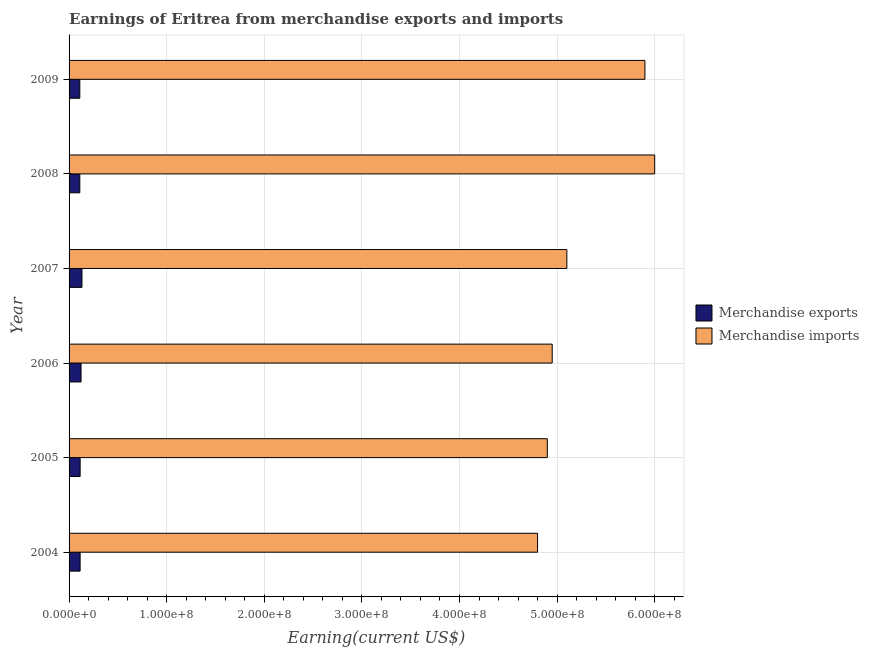How many different coloured bars are there?
Your answer should be very brief. 2. How many groups of bars are there?
Your answer should be very brief. 6. Are the number of bars per tick equal to the number of legend labels?
Keep it short and to the point. Yes. How many bars are there on the 1st tick from the top?
Ensure brevity in your answer.  2. What is the label of the 4th group of bars from the top?
Provide a short and direct response. 2006. In how many cases, is the number of bars for a given year not equal to the number of legend labels?
Provide a succinct answer. 0. What is the earnings from merchandise imports in 2005?
Ensure brevity in your answer.  4.90e+08. Across all years, what is the maximum earnings from merchandise imports?
Offer a terse response. 6.00e+08. Across all years, what is the minimum earnings from merchandise imports?
Make the answer very short. 4.80e+08. In which year was the earnings from merchandise imports maximum?
Your answer should be very brief. 2008. What is the total earnings from merchandise exports in the graph?
Give a very brief answer. 7.01e+07. What is the difference between the earnings from merchandise exports in 2005 and that in 2007?
Offer a very short reply. -1.90e+06. What is the difference between the earnings from merchandise imports in 2008 and the earnings from merchandise exports in 2004?
Keep it short and to the point. 5.89e+08. What is the average earnings from merchandise exports per year?
Your answer should be very brief. 1.17e+07. In the year 2005, what is the difference between the earnings from merchandise imports and earnings from merchandise exports?
Provide a succinct answer. 4.79e+08. What is the ratio of the earnings from merchandise imports in 2006 to that in 2007?
Provide a succinct answer. 0.97. Is the earnings from merchandise imports in 2005 less than that in 2006?
Ensure brevity in your answer.  Yes. What is the difference between the highest and the lowest earnings from merchandise exports?
Keep it short and to the point. 2.22e+06. What does the 2nd bar from the top in 2006 represents?
Offer a very short reply. Merchandise exports. Are all the bars in the graph horizontal?
Keep it short and to the point. Yes. Does the graph contain any zero values?
Provide a short and direct response. No. How are the legend labels stacked?
Provide a short and direct response. Vertical. What is the title of the graph?
Provide a succinct answer. Earnings of Eritrea from merchandise exports and imports. Does "Not attending school" appear as one of the legend labels in the graph?
Give a very brief answer. No. What is the label or title of the X-axis?
Give a very brief answer. Earning(current US$). What is the Earning(current US$) in Merchandise exports in 2004?
Provide a short and direct response. 1.13e+07. What is the Earning(current US$) in Merchandise imports in 2004?
Provide a succinct answer. 4.80e+08. What is the Earning(current US$) in Merchandise exports in 2005?
Give a very brief answer. 1.13e+07. What is the Earning(current US$) in Merchandise imports in 2005?
Your response must be concise. 4.90e+08. What is the Earning(current US$) in Merchandise exports in 2006?
Provide a short and direct response. 1.23e+07. What is the Earning(current US$) in Merchandise imports in 2006?
Make the answer very short. 4.95e+08. What is the Earning(current US$) of Merchandise exports in 2007?
Ensure brevity in your answer.  1.32e+07. What is the Earning(current US$) in Merchandise imports in 2007?
Your answer should be very brief. 5.10e+08. What is the Earning(current US$) of Merchandise exports in 2008?
Give a very brief answer. 1.10e+07. What is the Earning(current US$) of Merchandise imports in 2008?
Offer a very short reply. 6.00e+08. What is the Earning(current US$) in Merchandise exports in 2009?
Offer a very short reply. 1.10e+07. What is the Earning(current US$) of Merchandise imports in 2009?
Ensure brevity in your answer.  5.90e+08. Across all years, what is the maximum Earning(current US$) in Merchandise exports?
Make the answer very short. 1.32e+07. Across all years, what is the maximum Earning(current US$) in Merchandise imports?
Offer a terse response. 6.00e+08. Across all years, what is the minimum Earning(current US$) in Merchandise exports?
Offer a terse response. 1.10e+07. Across all years, what is the minimum Earning(current US$) in Merchandise imports?
Make the answer very short. 4.80e+08. What is the total Earning(current US$) in Merchandise exports in the graph?
Make the answer very short. 7.01e+07. What is the total Earning(current US$) of Merchandise imports in the graph?
Ensure brevity in your answer.  3.16e+09. What is the difference between the Earning(current US$) in Merchandise imports in 2004 and that in 2005?
Give a very brief answer. -1.00e+07. What is the difference between the Earning(current US$) in Merchandise exports in 2004 and that in 2006?
Give a very brief answer. -9.60e+05. What is the difference between the Earning(current US$) in Merchandise imports in 2004 and that in 2006?
Make the answer very short. -1.50e+07. What is the difference between the Earning(current US$) in Merchandise exports in 2004 and that in 2007?
Your response must be concise. -1.91e+06. What is the difference between the Earning(current US$) in Merchandise imports in 2004 and that in 2007?
Keep it short and to the point. -3.00e+07. What is the difference between the Earning(current US$) of Merchandise exports in 2004 and that in 2008?
Provide a succinct answer. 3.10e+05. What is the difference between the Earning(current US$) of Merchandise imports in 2004 and that in 2008?
Offer a terse response. -1.20e+08. What is the difference between the Earning(current US$) in Merchandise imports in 2004 and that in 2009?
Ensure brevity in your answer.  -1.10e+08. What is the difference between the Earning(current US$) in Merchandise exports in 2005 and that in 2006?
Make the answer very short. -9.50e+05. What is the difference between the Earning(current US$) of Merchandise imports in 2005 and that in 2006?
Provide a short and direct response. -5.00e+06. What is the difference between the Earning(current US$) of Merchandise exports in 2005 and that in 2007?
Provide a succinct answer. -1.90e+06. What is the difference between the Earning(current US$) of Merchandise imports in 2005 and that in 2007?
Offer a terse response. -2.00e+07. What is the difference between the Earning(current US$) in Merchandise imports in 2005 and that in 2008?
Give a very brief answer. -1.10e+08. What is the difference between the Earning(current US$) of Merchandise exports in 2005 and that in 2009?
Your response must be concise. 3.20e+05. What is the difference between the Earning(current US$) in Merchandise imports in 2005 and that in 2009?
Offer a terse response. -1.00e+08. What is the difference between the Earning(current US$) in Merchandise exports in 2006 and that in 2007?
Keep it short and to the point. -9.50e+05. What is the difference between the Earning(current US$) of Merchandise imports in 2006 and that in 2007?
Provide a succinct answer. -1.50e+07. What is the difference between the Earning(current US$) in Merchandise exports in 2006 and that in 2008?
Keep it short and to the point. 1.27e+06. What is the difference between the Earning(current US$) of Merchandise imports in 2006 and that in 2008?
Offer a terse response. -1.05e+08. What is the difference between the Earning(current US$) in Merchandise exports in 2006 and that in 2009?
Offer a terse response. 1.27e+06. What is the difference between the Earning(current US$) in Merchandise imports in 2006 and that in 2009?
Your answer should be very brief. -9.50e+07. What is the difference between the Earning(current US$) of Merchandise exports in 2007 and that in 2008?
Your answer should be very brief. 2.22e+06. What is the difference between the Earning(current US$) of Merchandise imports in 2007 and that in 2008?
Provide a short and direct response. -9.00e+07. What is the difference between the Earning(current US$) in Merchandise exports in 2007 and that in 2009?
Keep it short and to the point. 2.22e+06. What is the difference between the Earning(current US$) of Merchandise imports in 2007 and that in 2009?
Offer a very short reply. -8.00e+07. What is the difference between the Earning(current US$) in Merchandise imports in 2008 and that in 2009?
Provide a short and direct response. 1.00e+07. What is the difference between the Earning(current US$) in Merchandise exports in 2004 and the Earning(current US$) in Merchandise imports in 2005?
Provide a succinct answer. -4.79e+08. What is the difference between the Earning(current US$) of Merchandise exports in 2004 and the Earning(current US$) of Merchandise imports in 2006?
Offer a very short reply. -4.84e+08. What is the difference between the Earning(current US$) of Merchandise exports in 2004 and the Earning(current US$) of Merchandise imports in 2007?
Ensure brevity in your answer.  -4.99e+08. What is the difference between the Earning(current US$) of Merchandise exports in 2004 and the Earning(current US$) of Merchandise imports in 2008?
Provide a succinct answer. -5.89e+08. What is the difference between the Earning(current US$) in Merchandise exports in 2004 and the Earning(current US$) in Merchandise imports in 2009?
Ensure brevity in your answer.  -5.79e+08. What is the difference between the Earning(current US$) of Merchandise exports in 2005 and the Earning(current US$) of Merchandise imports in 2006?
Keep it short and to the point. -4.84e+08. What is the difference between the Earning(current US$) in Merchandise exports in 2005 and the Earning(current US$) in Merchandise imports in 2007?
Your answer should be compact. -4.99e+08. What is the difference between the Earning(current US$) in Merchandise exports in 2005 and the Earning(current US$) in Merchandise imports in 2008?
Make the answer very short. -5.89e+08. What is the difference between the Earning(current US$) in Merchandise exports in 2005 and the Earning(current US$) in Merchandise imports in 2009?
Provide a succinct answer. -5.79e+08. What is the difference between the Earning(current US$) in Merchandise exports in 2006 and the Earning(current US$) in Merchandise imports in 2007?
Ensure brevity in your answer.  -4.98e+08. What is the difference between the Earning(current US$) in Merchandise exports in 2006 and the Earning(current US$) in Merchandise imports in 2008?
Offer a terse response. -5.88e+08. What is the difference between the Earning(current US$) in Merchandise exports in 2006 and the Earning(current US$) in Merchandise imports in 2009?
Provide a short and direct response. -5.78e+08. What is the difference between the Earning(current US$) of Merchandise exports in 2007 and the Earning(current US$) of Merchandise imports in 2008?
Offer a very short reply. -5.87e+08. What is the difference between the Earning(current US$) of Merchandise exports in 2007 and the Earning(current US$) of Merchandise imports in 2009?
Make the answer very short. -5.77e+08. What is the difference between the Earning(current US$) in Merchandise exports in 2008 and the Earning(current US$) in Merchandise imports in 2009?
Your response must be concise. -5.79e+08. What is the average Earning(current US$) in Merchandise exports per year?
Make the answer very short. 1.17e+07. What is the average Earning(current US$) of Merchandise imports per year?
Your response must be concise. 5.28e+08. In the year 2004, what is the difference between the Earning(current US$) of Merchandise exports and Earning(current US$) of Merchandise imports?
Your answer should be compact. -4.69e+08. In the year 2005, what is the difference between the Earning(current US$) of Merchandise exports and Earning(current US$) of Merchandise imports?
Keep it short and to the point. -4.79e+08. In the year 2006, what is the difference between the Earning(current US$) in Merchandise exports and Earning(current US$) in Merchandise imports?
Offer a very short reply. -4.83e+08. In the year 2007, what is the difference between the Earning(current US$) of Merchandise exports and Earning(current US$) of Merchandise imports?
Offer a terse response. -4.97e+08. In the year 2008, what is the difference between the Earning(current US$) of Merchandise exports and Earning(current US$) of Merchandise imports?
Provide a succinct answer. -5.89e+08. In the year 2009, what is the difference between the Earning(current US$) in Merchandise exports and Earning(current US$) in Merchandise imports?
Your answer should be very brief. -5.79e+08. What is the ratio of the Earning(current US$) in Merchandise exports in 2004 to that in 2005?
Your answer should be very brief. 1. What is the ratio of the Earning(current US$) of Merchandise imports in 2004 to that in 2005?
Your answer should be very brief. 0.98. What is the ratio of the Earning(current US$) of Merchandise exports in 2004 to that in 2006?
Provide a succinct answer. 0.92. What is the ratio of the Earning(current US$) of Merchandise imports in 2004 to that in 2006?
Make the answer very short. 0.97. What is the ratio of the Earning(current US$) of Merchandise exports in 2004 to that in 2007?
Provide a succinct answer. 0.86. What is the ratio of the Earning(current US$) in Merchandise imports in 2004 to that in 2007?
Keep it short and to the point. 0.94. What is the ratio of the Earning(current US$) in Merchandise exports in 2004 to that in 2008?
Keep it short and to the point. 1.03. What is the ratio of the Earning(current US$) in Merchandise exports in 2004 to that in 2009?
Offer a terse response. 1.03. What is the ratio of the Earning(current US$) of Merchandise imports in 2004 to that in 2009?
Offer a very short reply. 0.81. What is the ratio of the Earning(current US$) of Merchandise exports in 2005 to that in 2006?
Keep it short and to the point. 0.92. What is the ratio of the Earning(current US$) of Merchandise exports in 2005 to that in 2007?
Provide a succinct answer. 0.86. What is the ratio of the Earning(current US$) of Merchandise imports in 2005 to that in 2007?
Keep it short and to the point. 0.96. What is the ratio of the Earning(current US$) of Merchandise exports in 2005 to that in 2008?
Provide a succinct answer. 1.03. What is the ratio of the Earning(current US$) in Merchandise imports in 2005 to that in 2008?
Provide a succinct answer. 0.82. What is the ratio of the Earning(current US$) in Merchandise exports in 2005 to that in 2009?
Your answer should be very brief. 1.03. What is the ratio of the Earning(current US$) in Merchandise imports in 2005 to that in 2009?
Provide a succinct answer. 0.83. What is the ratio of the Earning(current US$) of Merchandise exports in 2006 to that in 2007?
Keep it short and to the point. 0.93. What is the ratio of the Earning(current US$) of Merchandise imports in 2006 to that in 2007?
Ensure brevity in your answer.  0.97. What is the ratio of the Earning(current US$) in Merchandise exports in 2006 to that in 2008?
Your answer should be compact. 1.12. What is the ratio of the Earning(current US$) in Merchandise imports in 2006 to that in 2008?
Provide a short and direct response. 0.82. What is the ratio of the Earning(current US$) in Merchandise exports in 2006 to that in 2009?
Your answer should be compact. 1.12. What is the ratio of the Earning(current US$) of Merchandise imports in 2006 to that in 2009?
Give a very brief answer. 0.84. What is the ratio of the Earning(current US$) of Merchandise exports in 2007 to that in 2008?
Provide a short and direct response. 1.2. What is the ratio of the Earning(current US$) in Merchandise exports in 2007 to that in 2009?
Offer a very short reply. 1.2. What is the ratio of the Earning(current US$) of Merchandise imports in 2007 to that in 2009?
Provide a short and direct response. 0.86. What is the ratio of the Earning(current US$) of Merchandise imports in 2008 to that in 2009?
Offer a terse response. 1.02. What is the difference between the highest and the second highest Earning(current US$) of Merchandise exports?
Offer a very short reply. 9.50e+05. What is the difference between the highest and the second highest Earning(current US$) of Merchandise imports?
Give a very brief answer. 1.00e+07. What is the difference between the highest and the lowest Earning(current US$) of Merchandise exports?
Your answer should be compact. 2.22e+06. What is the difference between the highest and the lowest Earning(current US$) of Merchandise imports?
Make the answer very short. 1.20e+08. 